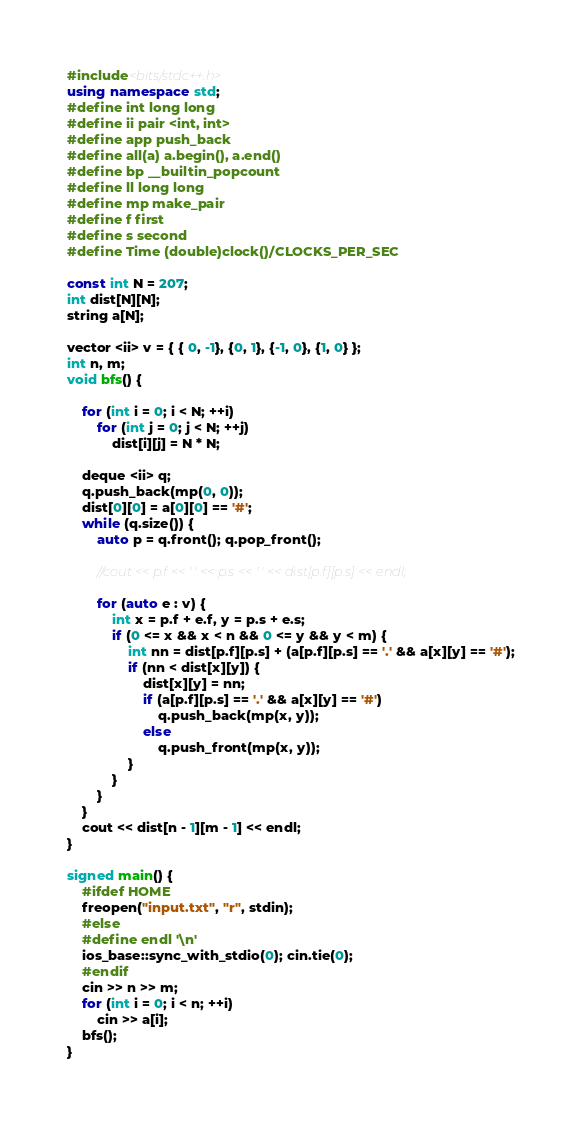<code> <loc_0><loc_0><loc_500><loc_500><_C++_>#include<bits/stdc++.h>
using namespace std;
#define int long long
#define ii pair <int, int>
#define app push_back
#define all(a) a.begin(), a.end()
#define bp __builtin_popcount
#define ll long long
#define mp make_pair
#define f first
#define s second
#define Time (double)clock()/CLOCKS_PER_SEC

const int N = 207;
int dist[N][N];
string a[N];

vector <ii> v = { { 0, -1}, {0, 1}, {-1, 0}, {1, 0} };
int n, m;
void bfs() {

    for (int i = 0; i < N; ++i)
        for (int j = 0; j < N; ++j)
            dist[i][j] = N * N;

    deque <ii> q;
    q.push_back(mp(0, 0));
    dist[0][0] = a[0][0] == '#';
    while (q.size()) {
        auto p = q.front(); q.pop_front();

        //cout << p.f << ' ' << p.s << ' ' << dist[p.f][p.s] << endl;

        for (auto e : v) {
            int x = p.f + e.f, y = p.s + e.s;
            if (0 <= x && x < n && 0 <= y && y < m) {
                int nn = dist[p.f][p.s] + (a[p.f][p.s] == '.' && a[x][y] == '#');
                if (nn < dist[x][y]) {
                    dist[x][y] = nn;
                    if (a[p.f][p.s] == '.' && a[x][y] == '#')
                        q.push_back(mp(x, y));
                    else
                        q.push_front(mp(x, y));
                }
            }   
        }   
    }   
    cout << dist[n - 1][m - 1] << endl;
}   

signed main() {
    #ifdef HOME
    freopen("input.txt", "r", stdin);
    #else
    #define endl '\n'
    ios_base::sync_with_stdio(0); cin.tie(0);
    #endif
    cin >> n >> m;
    for (int i = 0; i < n; ++i)
        cin >> a[i];
    bfs();            
}   </code> 